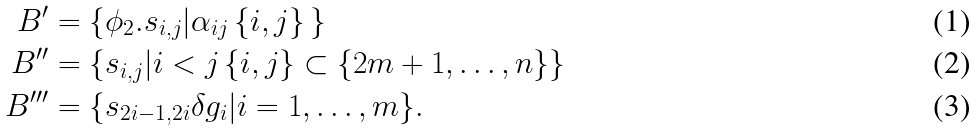<formula> <loc_0><loc_0><loc_500><loc_500>B ^ { \prime } & = \{ \phi _ { 2 } . s _ { i , j } | \alpha _ { i j } \, \{ i , j \} \, \} \\ B ^ { \prime \prime } & = \{ s _ { i , j } | i < j \, \{ i , j \} \subset \{ 2 m + 1 , \dots , n \} \} \\ B ^ { \prime \prime \prime } & = \{ s _ { 2 i - 1 , 2 i } \delta g _ { i } | i = 1 , \dots , m \} .</formula> 